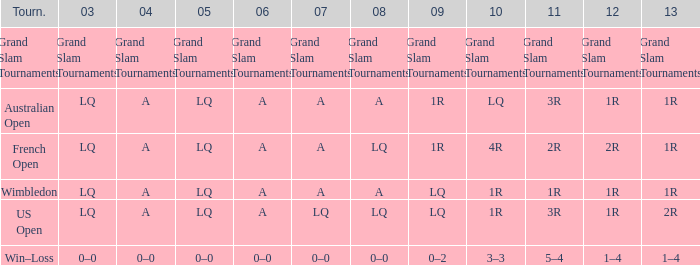Which year has a 2011 of 1r? A. 